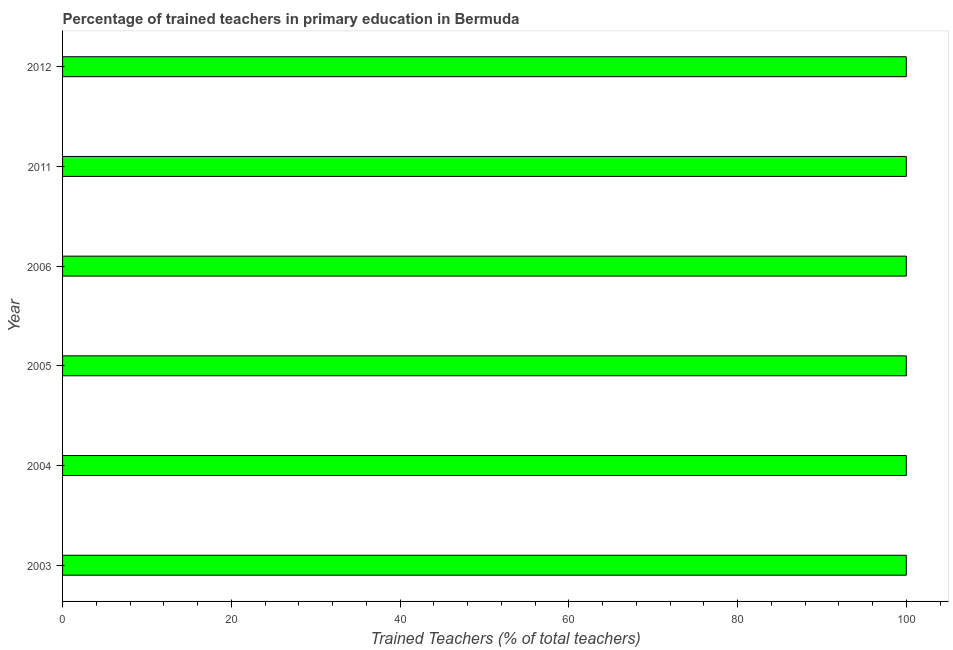Does the graph contain grids?
Provide a succinct answer. No. What is the title of the graph?
Provide a short and direct response. Percentage of trained teachers in primary education in Bermuda. What is the label or title of the X-axis?
Provide a short and direct response. Trained Teachers (% of total teachers). What is the label or title of the Y-axis?
Offer a very short reply. Year. What is the percentage of trained teachers in 2005?
Provide a succinct answer. 100. Across all years, what is the minimum percentage of trained teachers?
Offer a terse response. 100. In which year was the percentage of trained teachers maximum?
Your answer should be compact. 2003. What is the sum of the percentage of trained teachers?
Keep it short and to the point. 600. What is the average percentage of trained teachers per year?
Keep it short and to the point. 100. What is the median percentage of trained teachers?
Offer a very short reply. 100. Do a majority of the years between 2006 and 2012 (inclusive) have percentage of trained teachers greater than 56 %?
Provide a succinct answer. Yes. What is the difference between the highest and the second highest percentage of trained teachers?
Give a very brief answer. 0. Is the sum of the percentage of trained teachers in 2003 and 2011 greater than the maximum percentage of trained teachers across all years?
Your answer should be compact. Yes. In how many years, is the percentage of trained teachers greater than the average percentage of trained teachers taken over all years?
Provide a succinct answer. 0. How many years are there in the graph?
Give a very brief answer. 6. What is the Trained Teachers (% of total teachers) of 2004?
Offer a very short reply. 100. What is the Trained Teachers (% of total teachers) of 2006?
Keep it short and to the point. 100. What is the difference between the Trained Teachers (% of total teachers) in 2003 and 2005?
Your response must be concise. 0. What is the difference between the Trained Teachers (% of total teachers) in 2003 and 2011?
Provide a short and direct response. 0. What is the difference between the Trained Teachers (% of total teachers) in 2004 and 2006?
Your answer should be compact. 0. What is the difference between the Trained Teachers (% of total teachers) in 2004 and 2012?
Your answer should be compact. 0. What is the difference between the Trained Teachers (% of total teachers) in 2005 and 2006?
Your answer should be very brief. 0. What is the difference between the Trained Teachers (% of total teachers) in 2005 and 2011?
Your response must be concise. 0. What is the difference between the Trained Teachers (% of total teachers) in 2006 and 2012?
Your answer should be very brief. 0. What is the ratio of the Trained Teachers (% of total teachers) in 2003 to that in 2006?
Give a very brief answer. 1. What is the ratio of the Trained Teachers (% of total teachers) in 2003 to that in 2011?
Offer a very short reply. 1. What is the ratio of the Trained Teachers (% of total teachers) in 2004 to that in 2005?
Your answer should be compact. 1. What is the ratio of the Trained Teachers (% of total teachers) in 2004 to that in 2012?
Keep it short and to the point. 1. What is the ratio of the Trained Teachers (% of total teachers) in 2005 to that in 2006?
Ensure brevity in your answer.  1. What is the ratio of the Trained Teachers (% of total teachers) in 2005 to that in 2011?
Offer a terse response. 1. What is the ratio of the Trained Teachers (% of total teachers) in 2005 to that in 2012?
Provide a succinct answer. 1. What is the ratio of the Trained Teachers (% of total teachers) in 2011 to that in 2012?
Ensure brevity in your answer.  1. 